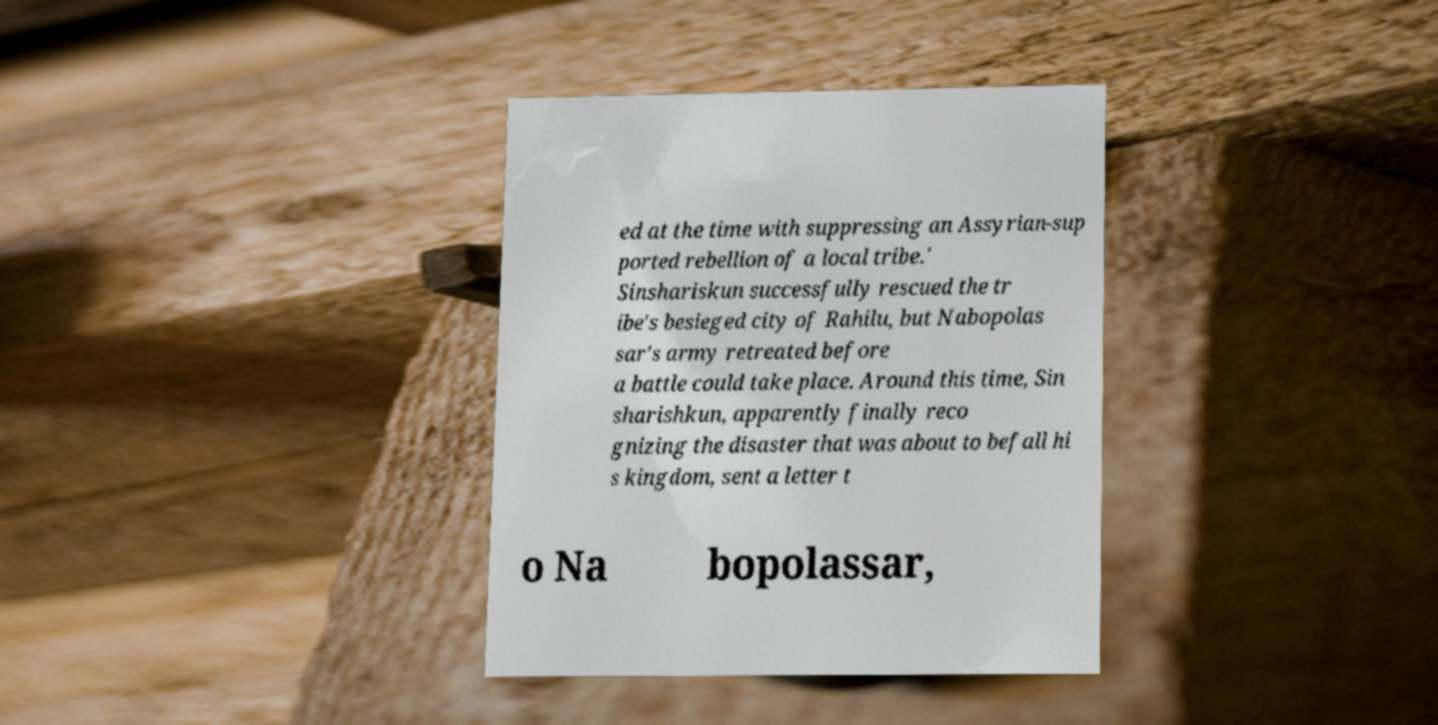I need the written content from this picture converted into text. Can you do that? ed at the time with suppressing an Assyrian-sup ported rebellion of a local tribe.' Sinshariskun successfully rescued the tr ibe's besieged city of Rahilu, but Nabopolas sar's army retreated before a battle could take place. Around this time, Sin sharishkun, apparently finally reco gnizing the disaster that was about to befall hi s kingdom, sent a letter t o Na bopolassar, 